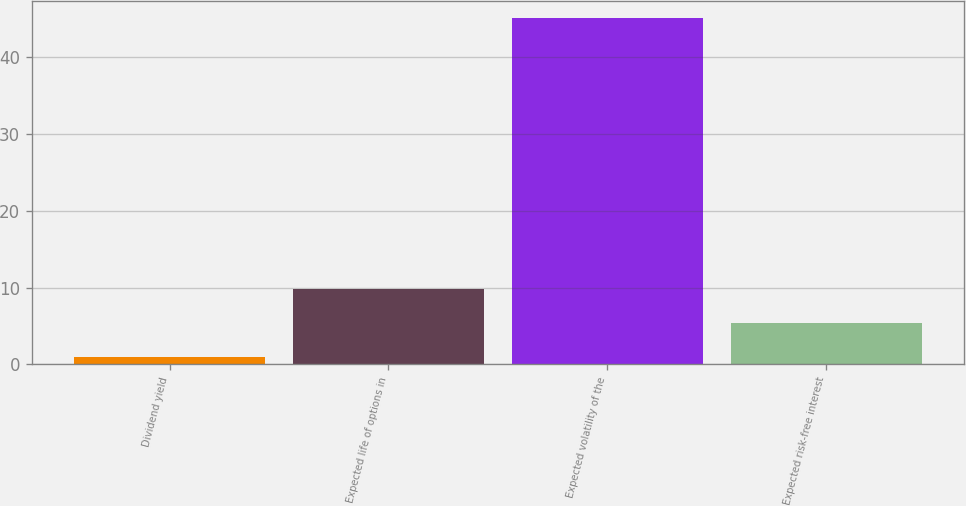<chart> <loc_0><loc_0><loc_500><loc_500><bar_chart><fcel>Dividend yield<fcel>Expected life of options in<fcel>Expected volatility of the<fcel>Expected risk-free interest<nl><fcel>0.93<fcel>9.77<fcel>45.1<fcel>5.35<nl></chart> 